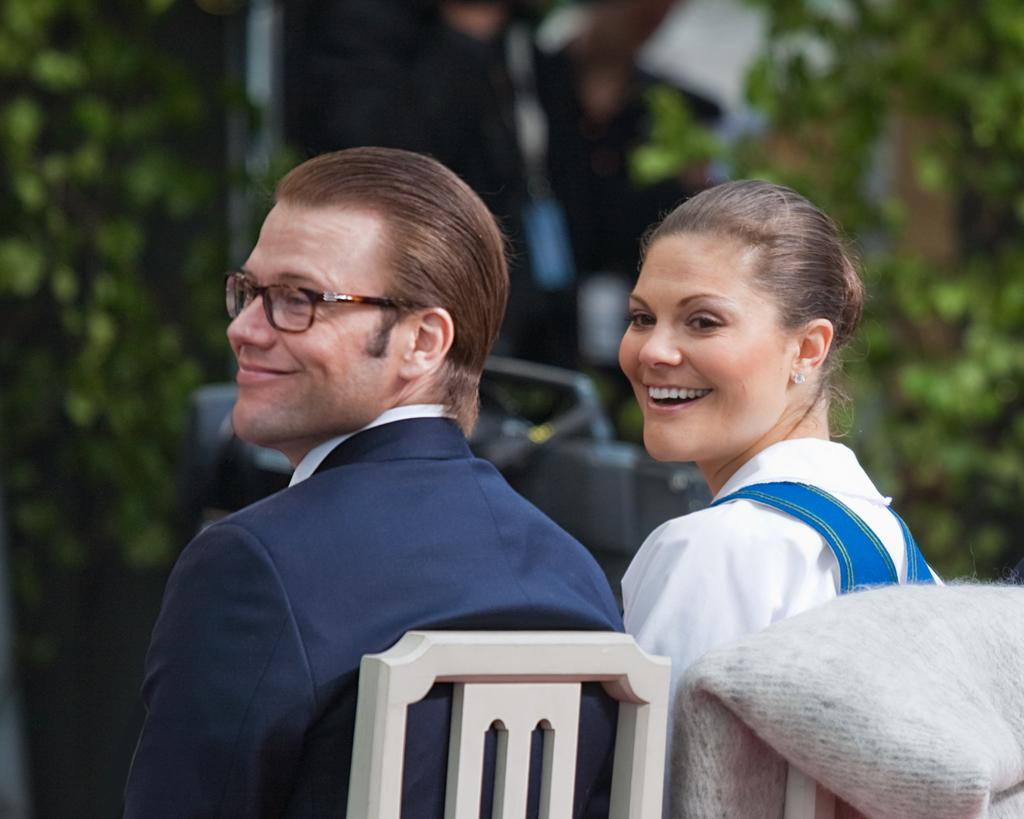What is the gender of the person in the image? The person in the image is a woman. What is the woman doing in the image? The woman is sitting on a chair. What can be seen in the background of the image? There are trees visible in the image. What type of oatmeal is the woman eating in the image? There is no oatmeal present in the image, and the woman is not eating anything. How many partners does the woman have in the image? There is no mention of a partner or partners in the image, so it cannot be determined. 